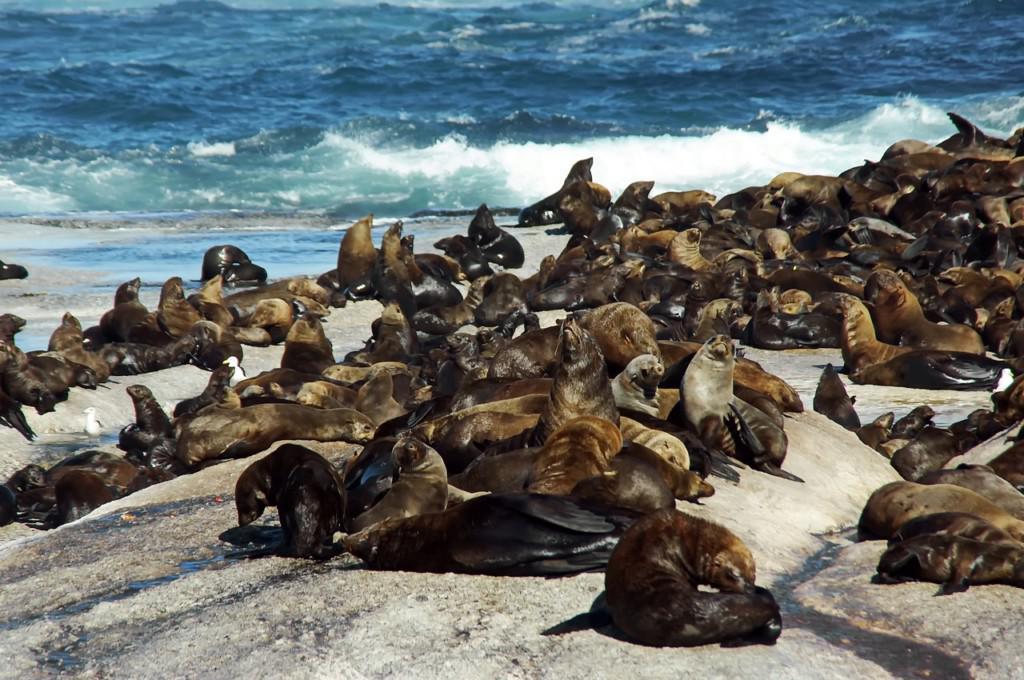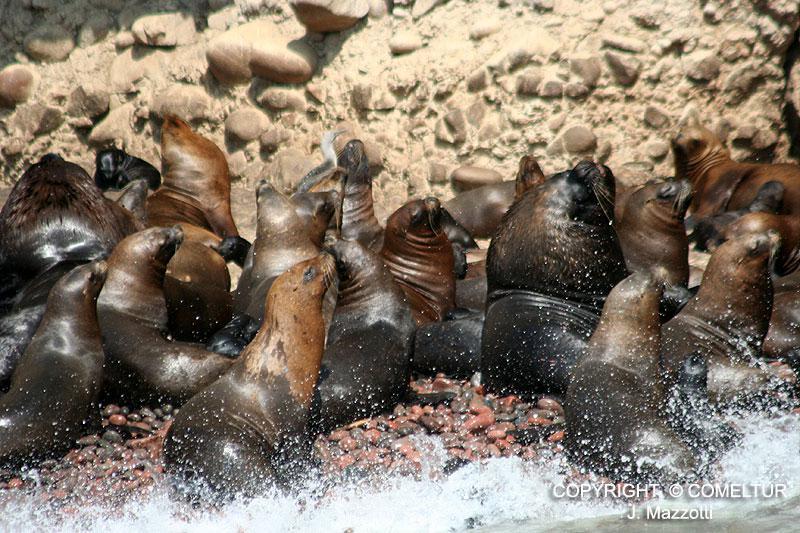The first image is the image on the left, the second image is the image on the right. Considering the images on both sides, is "Each image shows a mass of at least 15 seals on a natural elevated surface with water visible next to it." valid? Answer yes or no. Yes. The first image is the image on the left, the second image is the image on the right. Given the left and right images, does the statement "Waves are coming onto the beach." hold true? Answer yes or no. Yes. 